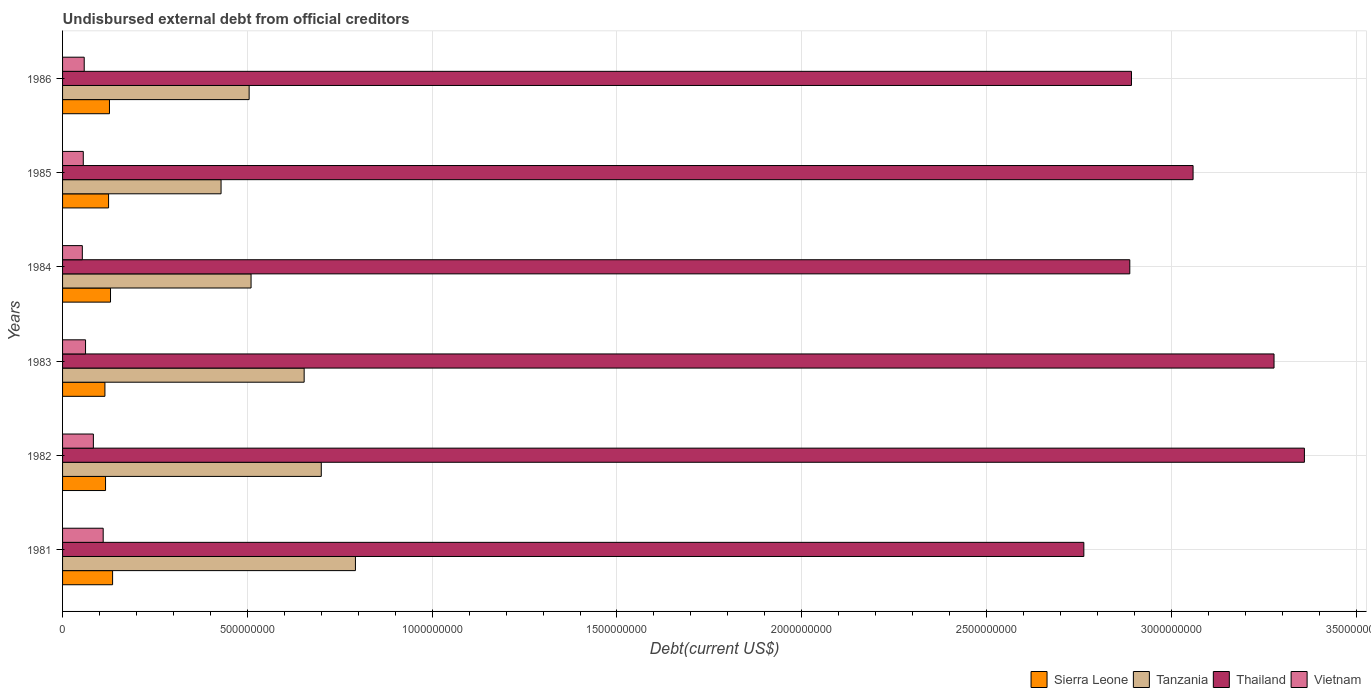How many bars are there on the 2nd tick from the top?
Keep it short and to the point. 4. How many bars are there on the 3rd tick from the bottom?
Offer a very short reply. 4. What is the total debt in Sierra Leone in 1986?
Your answer should be compact. 1.27e+08. Across all years, what is the maximum total debt in Thailand?
Offer a terse response. 3.36e+09. Across all years, what is the minimum total debt in Thailand?
Ensure brevity in your answer.  2.76e+09. In which year was the total debt in Tanzania maximum?
Offer a very short reply. 1981. What is the total total debt in Tanzania in the graph?
Your response must be concise. 3.59e+09. What is the difference between the total debt in Thailand in 1985 and that in 1986?
Give a very brief answer. 1.67e+08. What is the difference between the total debt in Tanzania in 1981 and the total debt in Vietnam in 1985?
Make the answer very short. 7.36e+08. What is the average total debt in Sierra Leone per year?
Your answer should be very brief. 1.25e+08. In the year 1982, what is the difference between the total debt in Tanzania and total debt in Sierra Leone?
Provide a short and direct response. 5.84e+08. What is the ratio of the total debt in Thailand in 1982 to that in 1986?
Offer a terse response. 1.16. What is the difference between the highest and the second highest total debt in Thailand?
Your answer should be very brief. 8.22e+07. What is the difference between the highest and the lowest total debt in Tanzania?
Offer a terse response. 3.64e+08. Is the sum of the total debt in Tanzania in 1983 and 1985 greater than the maximum total debt in Sierra Leone across all years?
Provide a short and direct response. Yes. What does the 4th bar from the top in 1982 represents?
Provide a succinct answer. Sierra Leone. What does the 1st bar from the bottom in 1984 represents?
Offer a very short reply. Sierra Leone. Is it the case that in every year, the sum of the total debt in Vietnam and total debt in Tanzania is greater than the total debt in Thailand?
Give a very brief answer. No. How many bars are there?
Your answer should be very brief. 24. Are all the bars in the graph horizontal?
Your answer should be compact. Yes. How many years are there in the graph?
Make the answer very short. 6. Does the graph contain grids?
Your answer should be very brief. Yes. Where does the legend appear in the graph?
Ensure brevity in your answer.  Bottom right. How many legend labels are there?
Your answer should be compact. 4. What is the title of the graph?
Provide a succinct answer. Undisbursed external debt from official creditors. What is the label or title of the X-axis?
Keep it short and to the point. Debt(current US$). What is the Debt(current US$) in Sierra Leone in 1981?
Keep it short and to the point. 1.35e+08. What is the Debt(current US$) in Tanzania in 1981?
Offer a terse response. 7.92e+08. What is the Debt(current US$) in Thailand in 1981?
Give a very brief answer. 2.76e+09. What is the Debt(current US$) in Vietnam in 1981?
Keep it short and to the point. 1.10e+08. What is the Debt(current US$) of Sierra Leone in 1982?
Give a very brief answer. 1.16e+08. What is the Debt(current US$) in Tanzania in 1982?
Give a very brief answer. 7.00e+08. What is the Debt(current US$) of Thailand in 1982?
Offer a terse response. 3.36e+09. What is the Debt(current US$) in Vietnam in 1982?
Your response must be concise. 8.34e+07. What is the Debt(current US$) in Sierra Leone in 1983?
Your response must be concise. 1.15e+08. What is the Debt(current US$) in Tanzania in 1983?
Make the answer very short. 6.54e+08. What is the Debt(current US$) in Thailand in 1983?
Make the answer very short. 3.28e+09. What is the Debt(current US$) of Vietnam in 1983?
Give a very brief answer. 6.22e+07. What is the Debt(current US$) in Sierra Leone in 1984?
Offer a very short reply. 1.30e+08. What is the Debt(current US$) in Tanzania in 1984?
Ensure brevity in your answer.  5.10e+08. What is the Debt(current US$) of Thailand in 1984?
Your answer should be compact. 2.89e+09. What is the Debt(current US$) in Vietnam in 1984?
Make the answer very short. 5.35e+07. What is the Debt(current US$) of Sierra Leone in 1985?
Offer a very short reply. 1.24e+08. What is the Debt(current US$) in Tanzania in 1985?
Ensure brevity in your answer.  4.29e+08. What is the Debt(current US$) of Thailand in 1985?
Offer a terse response. 3.06e+09. What is the Debt(current US$) of Vietnam in 1985?
Your answer should be very brief. 5.60e+07. What is the Debt(current US$) of Sierra Leone in 1986?
Make the answer very short. 1.27e+08. What is the Debt(current US$) of Tanzania in 1986?
Offer a very short reply. 5.05e+08. What is the Debt(current US$) in Thailand in 1986?
Ensure brevity in your answer.  2.89e+09. What is the Debt(current US$) of Vietnam in 1986?
Your answer should be very brief. 5.86e+07. Across all years, what is the maximum Debt(current US$) of Sierra Leone?
Give a very brief answer. 1.35e+08. Across all years, what is the maximum Debt(current US$) of Tanzania?
Your answer should be very brief. 7.92e+08. Across all years, what is the maximum Debt(current US$) in Thailand?
Give a very brief answer. 3.36e+09. Across all years, what is the maximum Debt(current US$) in Vietnam?
Your response must be concise. 1.10e+08. Across all years, what is the minimum Debt(current US$) of Sierra Leone?
Your answer should be compact. 1.15e+08. Across all years, what is the minimum Debt(current US$) in Tanzania?
Your answer should be very brief. 4.29e+08. Across all years, what is the minimum Debt(current US$) in Thailand?
Keep it short and to the point. 2.76e+09. Across all years, what is the minimum Debt(current US$) in Vietnam?
Keep it short and to the point. 5.35e+07. What is the total Debt(current US$) of Sierra Leone in the graph?
Give a very brief answer. 7.47e+08. What is the total Debt(current US$) of Tanzania in the graph?
Give a very brief answer. 3.59e+09. What is the total Debt(current US$) in Thailand in the graph?
Your response must be concise. 1.82e+1. What is the total Debt(current US$) in Vietnam in the graph?
Make the answer very short. 4.24e+08. What is the difference between the Debt(current US$) in Sierra Leone in 1981 and that in 1982?
Keep it short and to the point. 1.91e+07. What is the difference between the Debt(current US$) in Tanzania in 1981 and that in 1982?
Ensure brevity in your answer.  9.24e+07. What is the difference between the Debt(current US$) of Thailand in 1981 and that in 1982?
Your answer should be very brief. -5.97e+08. What is the difference between the Debt(current US$) of Vietnam in 1981 and that in 1982?
Keep it short and to the point. 2.65e+07. What is the difference between the Debt(current US$) in Sierra Leone in 1981 and that in 1983?
Make the answer very short. 2.08e+07. What is the difference between the Debt(current US$) in Tanzania in 1981 and that in 1983?
Give a very brief answer. 1.39e+08. What is the difference between the Debt(current US$) of Thailand in 1981 and that in 1983?
Provide a succinct answer. -5.15e+08. What is the difference between the Debt(current US$) in Vietnam in 1981 and that in 1983?
Provide a short and direct response. 4.77e+07. What is the difference between the Debt(current US$) of Sierra Leone in 1981 and that in 1984?
Provide a succinct answer. 5.64e+06. What is the difference between the Debt(current US$) in Tanzania in 1981 and that in 1984?
Offer a very short reply. 2.82e+08. What is the difference between the Debt(current US$) of Thailand in 1981 and that in 1984?
Give a very brief answer. -1.24e+08. What is the difference between the Debt(current US$) in Vietnam in 1981 and that in 1984?
Provide a short and direct response. 5.64e+07. What is the difference between the Debt(current US$) in Sierra Leone in 1981 and that in 1985?
Provide a succinct answer. 1.09e+07. What is the difference between the Debt(current US$) of Tanzania in 1981 and that in 1985?
Your answer should be very brief. 3.64e+08. What is the difference between the Debt(current US$) of Thailand in 1981 and that in 1985?
Provide a short and direct response. -2.96e+08. What is the difference between the Debt(current US$) in Vietnam in 1981 and that in 1985?
Provide a succinct answer. 5.39e+07. What is the difference between the Debt(current US$) of Sierra Leone in 1981 and that in 1986?
Give a very brief answer. 8.49e+06. What is the difference between the Debt(current US$) in Tanzania in 1981 and that in 1986?
Your answer should be very brief. 2.88e+08. What is the difference between the Debt(current US$) in Thailand in 1981 and that in 1986?
Give a very brief answer. -1.29e+08. What is the difference between the Debt(current US$) of Vietnam in 1981 and that in 1986?
Offer a very short reply. 5.13e+07. What is the difference between the Debt(current US$) in Sierra Leone in 1982 and that in 1983?
Provide a short and direct response. 1.68e+06. What is the difference between the Debt(current US$) in Tanzania in 1982 and that in 1983?
Make the answer very short. 4.63e+07. What is the difference between the Debt(current US$) in Thailand in 1982 and that in 1983?
Provide a short and direct response. 8.22e+07. What is the difference between the Debt(current US$) of Vietnam in 1982 and that in 1983?
Your answer should be compact. 2.12e+07. What is the difference between the Debt(current US$) of Sierra Leone in 1982 and that in 1984?
Offer a very short reply. -1.35e+07. What is the difference between the Debt(current US$) in Tanzania in 1982 and that in 1984?
Keep it short and to the point. 1.90e+08. What is the difference between the Debt(current US$) in Thailand in 1982 and that in 1984?
Offer a very short reply. 4.72e+08. What is the difference between the Debt(current US$) in Vietnam in 1982 and that in 1984?
Your answer should be very brief. 2.99e+07. What is the difference between the Debt(current US$) in Sierra Leone in 1982 and that in 1985?
Offer a terse response. -8.21e+06. What is the difference between the Debt(current US$) in Tanzania in 1982 and that in 1985?
Keep it short and to the point. 2.71e+08. What is the difference between the Debt(current US$) in Thailand in 1982 and that in 1985?
Provide a short and direct response. 3.01e+08. What is the difference between the Debt(current US$) in Vietnam in 1982 and that in 1985?
Ensure brevity in your answer.  2.73e+07. What is the difference between the Debt(current US$) of Sierra Leone in 1982 and that in 1986?
Provide a short and direct response. -1.06e+07. What is the difference between the Debt(current US$) of Tanzania in 1982 and that in 1986?
Provide a short and direct response. 1.95e+08. What is the difference between the Debt(current US$) in Thailand in 1982 and that in 1986?
Make the answer very short. 4.68e+08. What is the difference between the Debt(current US$) in Vietnam in 1982 and that in 1986?
Offer a very short reply. 2.48e+07. What is the difference between the Debt(current US$) in Sierra Leone in 1983 and that in 1984?
Keep it short and to the point. -1.51e+07. What is the difference between the Debt(current US$) in Tanzania in 1983 and that in 1984?
Make the answer very short. 1.44e+08. What is the difference between the Debt(current US$) in Thailand in 1983 and that in 1984?
Your answer should be compact. 3.90e+08. What is the difference between the Debt(current US$) of Vietnam in 1983 and that in 1984?
Give a very brief answer. 8.70e+06. What is the difference between the Debt(current US$) of Sierra Leone in 1983 and that in 1985?
Ensure brevity in your answer.  -9.88e+06. What is the difference between the Debt(current US$) of Tanzania in 1983 and that in 1985?
Make the answer very short. 2.25e+08. What is the difference between the Debt(current US$) in Thailand in 1983 and that in 1985?
Make the answer very short. 2.19e+08. What is the difference between the Debt(current US$) of Vietnam in 1983 and that in 1985?
Give a very brief answer. 6.14e+06. What is the difference between the Debt(current US$) in Sierra Leone in 1983 and that in 1986?
Ensure brevity in your answer.  -1.23e+07. What is the difference between the Debt(current US$) in Tanzania in 1983 and that in 1986?
Your response must be concise. 1.49e+08. What is the difference between the Debt(current US$) of Thailand in 1983 and that in 1986?
Offer a very short reply. 3.86e+08. What is the difference between the Debt(current US$) in Vietnam in 1983 and that in 1986?
Your answer should be compact. 3.58e+06. What is the difference between the Debt(current US$) of Sierra Leone in 1984 and that in 1985?
Make the answer very short. 5.25e+06. What is the difference between the Debt(current US$) of Tanzania in 1984 and that in 1985?
Your answer should be very brief. 8.12e+07. What is the difference between the Debt(current US$) in Thailand in 1984 and that in 1985?
Make the answer very short. -1.71e+08. What is the difference between the Debt(current US$) in Vietnam in 1984 and that in 1985?
Offer a very short reply. -2.56e+06. What is the difference between the Debt(current US$) of Sierra Leone in 1984 and that in 1986?
Your answer should be very brief. 2.85e+06. What is the difference between the Debt(current US$) in Tanzania in 1984 and that in 1986?
Give a very brief answer. 5.18e+06. What is the difference between the Debt(current US$) in Thailand in 1984 and that in 1986?
Your answer should be compact. -4.50e+06. What is the difference between the Debt(current US$) of Vietnam in 1984 and that in 1986?
Ensure brevity in your answer.  -5.11e+06. What is the difference between the Debt(current US$) of Sierra Leone in 1985 and that in 1986?
Ensure brevity in your answer.  -2.40e+06. What is the difference between the Debt(current US$) in Tanzania in 1985 and that in 1986?
Your response must be concise. -7.60e+07. What is the difference between the Debt(current US$) in Thailand in 1985 and that in 1986?
Your response must be concise. 1.67e+08. What is the difference between the Debt(current US$) of Vietnam in 1985 and that in 1986?
Offer a very short reply. -2.55e+06. What is the difference between the Debt(current US$) of Sierra Leone in 1981 and the Debt(current US$) of Tanzania in 1982?
Provide a succinct answer. -5.65e+08. What is the difference between the Debt(current US$) in Sierra Leone in 1981 and the Debt(current US$) in Thailand in 1982?
Your answer should be very brief. -3.22e+09. What is the difference between the Debt(current US$) in Sierra Leone in 1981 and the Debt(current US$) in Vietnam in 1982?
Your answer should be very brief. 5.20e+07. What is the difference between the Debt(current US$) in Tanzania in 1981 and the Debt(current US$) in Thailand in 1982?
Offer a very short reply. -2.57e+09. What is the difference between the Debt(current US$) of Tanzania in 1981 and the Debt(current US$) of Vietnam in 1982?
Offer a very short reply. 7.09e+08. What is the difference between the Debt(current US$) of Thailand in 1981 and the Debt(current US$) of Vietnam in 1982?
Make the answer very short. 2.68e+09. What is the difference between the Debt(current US$) in Sierra Leone in 1981 and the Debt(current US$) in Tanzania in 1983?
Your answer should be very brief. -5.18e+08. What is the difference between the Debt(current US$) of Sierra Leone in 1981 and the Debt(current US$) of Thailand in 1983?
Offer a terse response. -3.14e+09. What is the difference between the Debt(current US$) of Sierra Leone in 1981 and the Debt(current US$) of Vietnam in 1983?
Keep it short and to the point. 7.32e+07. What is the difference between the Debt(current US$) of Tanzania in 1981 and the Debt(current US$) of Thailand in 1983?
Offer a very short reply. -2.49e+09. What is the difference between the Debt(current US$) in Tanzania in 1981 and the Debt(current US$) in Vietnam in 1983?
Make the answer very short. 7.30e+08. What is the difference between the Debt(current US$) of Thailand in 1981 and the Debt(current US$) of Vietnam in 1983?
Your answer should be very brief. 2.70e+09. What is the difference between the Debt(current US$) in Sierra Leone in 1981 and the Debt(current US$) in Tanzania in 1984?
Your response must be concise. -3.75e+08. What is the difference between the Debt(current US$) of Sierra Leone in 1981 and the Debt(current US$) of Thailand in 1984?
Keep it short and to the point. -2.75e+09. What is the difference between the Debt(current US$) in Sierra Leone in 1981 and the Debt(current US$) in Vietnam in 1984?
Your answer should be very brief. 8.19e+07. What is the difference between the Debt(current US$) of Tanzania in 1981 and the Debt(current US$) of Thailand in 1984?
Provide a succinct answer. -2.10e+09. What is the difference between the Debt(current US$) in Tanzania in 1981 and the Debt(current US$) in Vietnam in 1984?
Your answer should be very brief. 7.39e+08. What is the difference between the Debt(current US$) of Thailand in 1981 and the Debt(current US$) of Vietnam in 1984?
Your answer should be compact. 2.71e+09. What is the difference between the Debt(current US$) in Sierra Leone in 1981 and the Debt(current US$) in Tanzania in 1985?
Make the answer very short. -2.93e+08. What is the difference between the Debt(current US$) in Sierra Leone in 1981 and the Debt(current US$) in Thailand in 1985?
Offer a very short reply. -2.92e+09. What is the difference between the Debt(current US$) in Sierra Leone in 1981 and the Debt(current US$) in Vietnam in 1985?
Give a very brief answer. 7.93e+07. What is the difference between the Debt(current US$) in Tanzania in 1981 and the Debt(current US$) in Thailand in 1985?
Make the answer very short. -2.27e+09. What is the difference between the Debt(current US$) in Tanzania in 1981 and the Debt(current US$) in Vietnam in 1985?
Give a very brief answer. 7.36e+08. What is the difference between the Debt(current US$) of Thailand in 1981 and the Debt(current US$) of Vietnam in 1985?
Provide a short and direct response. 2.71e+09. What is the difference between the Debt(current US$) in Sierra Leone in 1981 and the Debt(current US$) in Tanzania in 1986?
Offer a very short reply. -3.69e+08. What is the difference between the Debt(current US$) of Sierra Leone in 1981 and the Debt(current US$) of Thailand in 1986?
Provide a short and direct response. -2.76e+09. What is the difference between the Debt(current US$) of Sierra Leone in 1981 and the Debt(current US$) of Vietnam in 1986?
Your answer should be compact. 7.68e+07. What is the difference between the Debt(current US$) of Tanzania in 1981 and the Debt(current US$) of Thailand in 1986?
Your response must be concise. -2.10e+09. What is the difference between the Debt(current US$) in Tanzania in 1981 and the Debt(current US$) in Vietnam in 1986?
Offer a very short reply. 7.34e+08. What is the difference between the Debt(current US$) of Thailand in 1981 and the Debt(current US$) of Vietnam in 1986?
Give a very brief answer. 2.70e+09. What is the difference between the Debt(current US$) of Sierra Leone in 1982 and the Debt(current US$) of Tanzania in 1983?
Give a very brief answer. -5.37e+08. What is the difference between the Debt(current US$) of Sierra Leone in 1982 and the Debt(current US$) of Thailand in 1983?
Your answer should be very brief. -3.16e+09. What is the difference between the Debt(current US$) in Sierra Leone in 1982 and the Debt(current US$) in Vietnam in 1983?
Provide a short and direct response. 5.41e+07. What is the difference between the Debt(current US$) in Tanzania in 1982 and the Debt(current US$) in Thailand in 1983?
Keep it short and to the point. -2.58e+09. What is the difference between the Debt(current US$) in Tanzania in 1982 and the Debt(current US$) in Vietnam in 1983?
Offer a very short reply. 6.38e+08. What is the difference between the Debt(current US$) in Thailand in 1982 and the Debt(current US$) in Vietnam in 1983?
Keep it short and to the point. 3.30e+09. What is the difference between the Debt(current US$) of Sierra Leone in 1982 and the Debt(current US$) of Tanzania in 1984?
Offer a very short reply. -3.94e+08. What is the difference between the Debt(current US$) in Sierra Leone in 1982 and the Debt(current US$) in Thailand in 1984?
Keep it short and to the point. -2.77e+09. What is the difference between the Debt(current US$) in Sierra Leone in 1982 and the Debt(current US$) in Vietnam in 1984?
Give a very brief answer. 6.28e+07. What is the difference between the Debt(current US$) in Tanzania in 1982 and the Debt(current US$) in Thailand in 1984?
Your answer should be very brief. -2.19e+09. What is the difference between the Debt(current US$) of Tanzania in 1982 and the Debt(current US$) of Vietnam in 1984?
Your response must be concise. 6.46e+08. What is the difference between the Debt(current US$) in Thailand in 1982 and the Debt(current US$) in Vietnam in 1984?
Ensure brevity in your answer.  3.31e+09. What is the difference between the Debt(current US$) in Sierra Leone in 1982 and the Debt(current US$) in Tanzania in 1985?
Provide a succinct answer. -3.13e+08. What is the difference between the Debt(current US$) in Sierra Leone in 1982 and the Debt(current US$) in Thailand in 1985?
Give a very brief answer. -2.94e+09. What is the difference between the Debt(current US$) of Sierra Leone in 1982 and the Debt(current US$) of Vietnam in 1985?
Ensure brevity in your answer.  6.02e+07. What is the difference between the Debt(current US$) in Tanzania in 1982 and the Debt(current US$) in Thailand in 1985?
Provide a short and direct response. -2.36e+09. What is the difference between the Debt(current US$) in Tanzania in 1982 and the Debt(current US$) in Vietnam in 1985?
Keep it short and to the point. 6.44e+08. What is the difference between the Debt(current US$) in Thailand in 1982 and the Debt(current US$) in Vietnam in 1985?
Make the answer very short. 3.30e+09. What is the difference between the Debt(current US$) in Sierra Leone in 1982 and the Debt(current US$) in Tanzania in 1986?
Give a very brief answer. -3.89e+08. What is the difference between the Debt(current US$) in Sierra Leone in 1982 and the Debt(current US$) in Thailand in 1986?
Your answer should be very brief. -2.78e+09. What is the difference between the Debt(current US$) in Sierra Leone in 1982 and the Debt(current US$) in Vietnam in 1986?
Ensure brevity in your answer.  5.77e+07. What is the difference between the Debt(current US$) in Tanzania in 1982 and the Debt(current US$) in Thailand in 1986?
Offer a terse response. -2.19e+09. What is the difference between the Debt(current US$) of Tanzania in 1982 and the Debt(current US$) of Vietnam in 1986?
Keep it short and to the point. 6.41e+08. What is the difference between the Debt(current US$) of Thailand in 1982 and the Debt(current US$) of Vietnam in 1986?
Make the answer very short. 3.30e+09. What is the difference between the Debt(current US$) of Sierra Leone in 1983 and the Debt(current US$) of Tanzania in 1984?
Your response must be concise. -3.95e+08. What is the difference between the Debt(current US$) of Sierra Leone in 1983 and the Debt(current US$) of Thailand in 1984?
Your answer should be compact. -2.77e+09. What is the difference between the Debt(current US$) of Sierra Leone in 1983 and the Debt(current US$) of Vietnam in 1984?
Offer a very short reply. 6.11e+07. What is the difference between the Debt(current US$) of Tanzania in 1983 and the Debt(current US$) of Thailand in 1984?
Your answer should be compact. -2.23e+09. What is the difference between the Debt(current US$) of Tanzania in 1983 and the Debt(current US$) of Vietnam in 1984?
Ensure brevity in your answer.  6.00e+08. What is the difference between the Debt(current US$) of Thailand in 1983 and the Debt(current US$) of Vietnam in 1984?
Offer a terse response. 3.22e+09. What is the difference between the Debt(current US$) of Sierra Leone in 1983 and the Debt(current US$) of Tanzania in 1985?
Offer a very short reply. -3.14e+08. What is the difference between the Debt(current US$) in Sierra Leone in 1983 and the Debt(current US$) in Thailand in 1985?
Your answer should be compact. -2.94e+09. What is the difference between the Debt(current US$) of Sierra Leone in 1983 and the Debt(current US$) of Vietnam in 1985?
Keep it short and to the point. 5.86e+07. What is the difference between the Debt(current US$) in Tanzania in 1983 and the Debt(current US$) in Thailand in 1985?
Your answer should be compact. -2.41e+09. What is the difference between the Debt(current US$) of Tanzania in 1983 and the Debt(current US$) of Vietnam in 1985?
Your answer should be very brief. 5.98e+08. What is the difference between the Debt(current US$) in Thailand in 1983 and the Debt(current US$) in Vietnam in 1985?
Offer a terse response. 3.22e+09. What is the difference between the Debt(current US$) of Sierra Leone in 1983 and the Debt(current US$) of Tanzania in 1986?
Provide a short and direct response. -3.90e+08. What is the difference between the Debt(current US$) in Sierra Leone in 1983 and the Debt(current US$) in Thailand in 1986?
Keep it short and to the point. -2.78e+09. What is the difference between the Debt(current US$) of Sierra Leone in 1983 and the Debt(current US$) of Vietnam in 1986?
Make the answer very short. 5.60e+07. What is the difference between the Debt(current US$) of Tanzania in 1983 and the Debt(current US$) of Thailand in 1986?
Keep it short and to the point. -2.24e+09. What is the difference between the Debt(current US$) of Tanzania in 1983 and the Debt(current US$) of Vietnam in 1986?
Your response must be concise. 5.95e+08. What is the difference between the Debt(current US$) in Thailand in 1983 and the Debt(current US$) in Vietnam in 1986?
Offer a very short reply. 3.22e+09. What is the difference between the Debt(current US$) in Sierra Leone in 1984 and the Debt(current US$) in Tanzania in 1985?
Keep it short and to the point. -2.99e+08. What is the difference between the Debt(current US$) of Sierra Leone in 1984 and the Debt(current US$) of Thailand in 1985?
Make the answer very short. -2.93e+09. What is the difference between the Debt(current US$) of Sierra Leone in 1984 and the Debt(current US$) of Vietnam in 1985?
Give a very brief answer. 7.37e+07. What is the difference between the Debt(current US$) in Tanzania in 1984 and the Debt(current US$) in Thailand in 1985?
Ensure brevity in your answer.  -2.55e+09. What is the difference between the Debt(current US$) of Tanzania in 1984 and the Debt(current US$) of Vietnam in 1985?
Give a very brief answer. 4.54e+08. What is the difference between the Debt(current US$) in Thailand in 1984 and the Debt(current US$) in Vietnam in 1985?
Offer a very short reply. 2.83e+09. What is the difference between the Debt(current US$) of Sierra Leone in 1984 and the Debt(current US$) of Tanzania in 1986?
Your response must be concise. -3.75e+08. What is the difference between the Debt(current US$) of Sierra Leone in 1984 and the Debt(current US$) of Thailand in 1986?
Make the answer very short. -2.76e+09. What is the difference between the Debt(current US$) of Sierra Leone in 1984 and the Debt(current US$) of Vietnam in 1986?
Offer a terse response. 7.11e+07. What is the difference between the Debt(current US$) of Tanzania in 1984 and the Debt(current US$) of Thailand in 1986?
Offer a terse response. -2.38e+09. What is the difference between the Debt(current US$) of Tanzania in 1984 and the Debt(current US$) of Vietnam in 1986?
Keep it short and to the point. 4.51e+08. What is the difference between the Debt(current US$) in Thailand in 1984 and the Debt(current US$) in Vietnam in 1986?
Provide a short and direct response. 2.83e+09. What is the difference between the Debt(current US$) in Sierra Leone in 1985 and the Debt(current US$) in Tanzania in 1986?
Provide a succinct answer. -3.80e+08. What is the difference between the Debt(current US$) of Sierra Leone in 1985 and the Debt(current US$) of Thailand in 1986?
Offer a terse response. -2.77e+09. What is the difference between the Debt(current US$) in Sierra Leone in 1985 and the Debt(current US$) in Vietnam in 1986?
Give a very brief answer. 6.59e+07. What is the difference between the Debt(current US$) in Tanzania in 1985 and the Debt(current US$) in Thailand in 1986?
Keep it short and to the point. -2.46e+09. What is the difference between the Debt(current US$) of Tanzania in 1985 and the Debt(current US$) of Vietnam in 1986?
Provide a succinct answer. 3.70e+08. What is the difference between the Debt(current US$) of Thailand in 1985 and the Debt(current US$) of Vietnam in 1986?
Your answer should be compact. 3.00e+09. What is the average Debt(current US$) of Sierra Leone per year?
Ensure brevity in your answer.  1.25e+08. What is the average Debt(current US$) of Tanzania per year?
Provide a succinct answer. 5.98e+08. What is the average Debt(current US$) in Thailand per year?
Make the answer very short. 3.04e+09. What is the average Debt(current US$) of Vietnam per year?
Your answer should be compact. 7.06e+07. In the year 1981, what is the difference between the Debt(current US$) in Sierra Leone and Debt(current US$) in Tanzania?
Provide a succinct answer. -6.57e+08. In the year 1981, what is the difference between the Debt(current US$) of Sierra Leone and Debt(current US$) of Thailand?
Give a very brief answer. -2.63e+09. In the year 1981, what is the difference between the Debt(current US$) of Sierra Leone and Debt(current US$) of Vietnam?
Your answer should be very brief. 2.55e+07. In the year 1981, what is the difference between the Debt(current US$) in Tanzania and Debt(current US$) in Thailand?
Make the answer very short. -1.97e+09. In the year 1981, what is the difference between the Debt(current US$) of Tanzania and Debt(current US$) of Vietnam?
Keep it short and to the point. 6.82e+08. In the year 1981, what is the difference between the Debt(current US$) in Thailand and Debt(current US$) in Vietnam?
Your answer should be compact. 2.65e+09. In the year 1982, what is the difference between the Debt(current US$) of Sierra Leone and Debt(current US$) of Tanzania?
Offer a very short reply. -5.84e+08. In the year 1982, what is the difference between the Debt(current US$) in Sierra Leone and Debt(current US$) in Thailand?
Provide a succinct answer. -3.24e+09. In the year 1982, what is the difference between the Debt(current US$) in Sierra Leone and Debt(current US$) in Vietnam?
Provide a succinct answer. 3.29e+07. In the year 1982, what is the difference between the Debt(current US$) of Tanzania and Debt(current US$) of Thailand?
Give a very brief answer. -2.66e+09. In the year 1982, what is the difference between the Debt(current US$) of Tanzania and Debt(current US$) of Vietnam?
Your response must be concise. 6.17e+08. In the year 1982, what is the difference between the Debt(current US$) in Thailand and Debt(current US$) in Vietnam?
Keep it short and to the point. 3.28e+09. In the year 1983, what is the difference between the Debt(current US$) in Sierra Leone and Debt(current US$) in Tanzania?
Give a very brief answer. -5.39e+08. In the year 1983, what is the difference between the Debt(current US$) of Sierra Leone and Debt(current US$) of Thailand?
Your response must be concise. -3.16e+09. In the year 1983, what is the difference between the Debt(current US$) of Sierra Leone and Debt(current US$) of Vietnam?
Your answer should be very brief. 5.24e+07. In the year 1983, what is the difference between the Debt(current US$) in Tanzania and Debt(current US$) in Thailand?
Provide a succinct answer. -2.62e+09. In the year 1983, what is the difference between the Debt(current US$) of Tanzania and Debt(current US$) of Vietnam?
Keep it short and to the point. 5.91e+08. In the year 1983, what is the difference between the Debt(current US$) in Thailand and Debt(current US$) in Vietnam?
Provide a short and direct response. 3.22e+09. In the year 1984, what is the difference between the Debt(current US$) in Sierra Leone and Debt(current US$) in Tanzania?
Give a very brief answer. -3.80e+08. In the year 1984, what is the difference between the Debt(current US$) of Sierra Leone and Debt(current US$) of Thailand?
Keep it short and to the point. -2.76e+09. In the year 1984, what is the difference between the Debt(current US$) of Sierra Leone and Debt(current US$) of Vietnam?
Make the answer very short. 7.62e+07. In the year 1984, what is the difference between the Debt(current US$) in Tanzania and Debt(current US$) in Thailand?
Offer a terse response. -2.38e+09. In the year 1984, what is the difference between the Debt(current US$) of Tanzania and Debt(current US$) of Vietnam?
Your response must be concise. 4.56e+08. In the year 1984, what is the difference between the Debt(current US$) of Thailand and Debt(current US$) of Vietnam?
Ensure brevity in your answer.  2.83e+09. In the year 1985, what is the difference between the Debt(current US$) of Sierra Leone and Debt(current US$) of Tanzania?
Offer a very short reply. -3.04e+08. In the year 1985, what is the difference between the Debt(current US$) of Sierra Leone and Debt(current US$) of Thailand?
Make the answer very short. -2.93e+09. In the year 1985, what is the difference between the Debt(current US$) in Sierra Leone and Debt(current US$) in Vietnam?
Give a very brief answer. 6.84e+07. In the year 1985, what is the difference between the Debt(current US$) of Tanzania and Debt(current US$) of Thailand?
Offer a terse response. -2.63e+09. In the year 1985, what is the difference between the Debt(current US$) in Tanzania and Debt(current US$) in Vietnam?
Your answer should be very brief. 3.73e+08. In the year 1985, what is the difference between the Debt(current US$) of Thailand and Debt(current US$) of Vietnam?
Provide a short and direct response. 3.00e+09. In the year 1986, what is the difference between the Debt(current US$) in Sierra Leone and Debt(current US$) in Tanzania?
Provide a short and direct response. -3.78e+08. In the year 1986, what is the difference between the Debt(current US$) of Sierra Leone and Debt(current US$) of Thailand?
Your answer should be very brief. -2.77e+09. In the year 1986, what is the difference between the Debt(current US$) in Sierra Leone and Debt(current US$) in Vietnam?
Your answer should be very brief. 6.83e+07. In the year 1986, what is the difference between the Debt(current US$) of Tanzania and Debt(current US$) of Thailand?
Your answer should be very brief. -2.39e+09. In the year 1986, what is the difference between the Debt(current US$) of Tanzania and Debt(current US$) of Vietnam?
Offer a very short reply. 4.46e+08. In the year 1986, what is the difference between the Debt(current US$) in Thailand and Debt(current US$) in Vietnam?
Ensure brevity in your answer.  2.83e+09. What is the ratio of the Debt(current US$) in Sierra Leone in 1981 to that in 1982?
Your answer should be very brief. 1.16. What is the ratio of the Debt(current US$) of Tanzania in 1981 to that in 1982?
Offer a terse response. 1.13. What is the ratio of the Debt(current US$) of Thailand in 1981 to that in 1982?
Keep it short and to the point. 0.82. What is the ratio of the Debt(current US$) in Vietnam in 1981 to that in 1982?
Provide a short and direct response. 1.32. What is the ratio of the Debt(current US$) in Sierra Leone in 1981 to that in 1983?
Your answer should be compact. 1.18. What is the ratio of the Debt(current US$) of Tanzania in 1981 to that in 1983?
Give a very brief answer. 1.21. What is the ratio of the Debt(current US$) of Thailand in 1981 to that in 1983?
Make the answer very short. 0.84. What is the ratio of the Debt(current US$) in Vietnam in 1981 to that in 1983?
Provide a succinct answer. 1.77. What is the ratio of the Debt(current US$) of Sierra Leone in 1981 to that in 1984?
Give a very brief answer. 1.04. What is the ratio of the Debt(current US$) in Tanzania in 1981 to that in 1984?
Provide a succinct answer. 1.55. What is the ratio of the Debt(current US$) in Thailand in 1981 to that in 1984?
Make the answer very short. 0.96. What is the ratio of the Debt(current US$) of Vietnam in 1981 to that in 1984?
Offer a terse response. 2.05. What is the ratio of the Debt(current US$) in Sierra Leone in 1981 to that in 1985?
Keep it short and to the point. 1.09. What is the ratio of the Debt(current US$) in Tanzania in 1981 to that in 1985?
Make the answer very short. 1.85. What is the ratio of the Debt(current US$) in Thailand in 1981 to that in 1985?
Give a very brief answer. 0.9. What is the ratio of the Debt(current US$) of Vietnam in 1981 to that in 1985?
Give a very brief answer. 1.96. What is the ratio of the Debt(current US$) in Sierra Leone in 1981 to that in 1986?
Your answer should be compact. 1.07. What is the ratio of the Debt(current US$) in Tanzania in 1981 to that in 1986?
Give a very brief answer. 1.57. What is the ratio of the Debt(current US$) in Thailand in 1981 to that in 1986?
Give a very brief answer. 0.96. What is the ratio of the Debt(current US$) of Vietnam in 1981 to that in 1986?
Ensure brevity in your answer.  1.88. What is the ratio of the Debt(current US$) in Sierra Leone in 1982 to that in 1983?
Your answer should be very brief. 1.01. What is the ratio of the Debt(current US$) in Tanzania in 1982 to that in 1983?
Give a very brief answer. 1.07. What is the ratio of the Debt(current US$) of Thailand in 1982 to that in 1983?
Keep it short and to the point. 1.03. What is the ratio of the Debt(current US$) in Vietnam in 1982 to that in 1983?
Provide a short and direct response. 1.34. What is the ratio of the Debt(current US$) in Sierra Leone in 1982 to that in 1984?
Make the answer very short. 0.9. What is the ratio of the Debt(current US$) in Tanzania in 1982 to that in 1984?
Provide a succinct answer. 1.37. What is the ratio of the Debt(current US$) in Thailand in 1982 to that in 1984?
Your answer should be compact. 1.16. What is the ratio of the Debt(current US$) in Vietnam in 1982 to that in 1984?
Your answer should be compact. 1.56. What is the ratio of the Debt(current US$) in Sierra Leone in 1982 to that in 1985?
Offer a very short reply. 0.93. What is the ratio of the Debt(current US$) of Tanzania in 1982 to that in 1985?
Give a very brief answer. 1.63. What is the ratio of the Debt(current US$) in Thailand in 1982 to that in 1985?
Ensure brevity in your answer.  1.1. What is the ratio of the Debt(current US$) of Vietnam in 1982 to that in 1985?
Offer a very short reply. 1.49. What is the ratio of the Debt(current US$) in Sierra Leone in 1982 to that in 1986?
Your answer should be compact. 0.92. What is the ratio of the Debt(current US$) of Tanzania in 1982 to that in 1986?
Offer a terse response. 1.39. What is the ratio of the Debt(current US$) in Thailand in 1982 to that in 1986?
Provide a short and direct response. 1.16. What is the ratio of the Debt(current US$) in Vietnam in 1982 to that in 1986?
Your answer should be compact. 1.42. What is the ratio of the Debt(current US$) of Sierra Leone in 1983 to that in 1984?
Ensure brevity in your answer.  0.88. What is the ratio of the Debt(current US$) of Tanzania in 1983 to that in 1984?
Give a very brief answer. 1.28. What is the ratio of the Debt(current US$) of Thailand in 1983 to that in 1984?
Provide a succinct answer. 1.14. What is the ratio of the Debt(current US$) in Vietnam in 1983 to that in 1984?
Keep it short and to the point. 1.16. What is the ratio of the Debt(current US$) of Sierra Leone in 1983 to that in 1985?
Offer a very short reply. 0.92. What is the ratio of the Debt(current US$) in Tanzania in 1983 to that in 1985?
Your response must be concise. 1.52. What is the ratio of the Debt(current US$) in Thailand in 1983 to that in 1985?
Offer a terse response. 1.07. What is the ratio of the Debt(current US$) in Vietnam in 1983 to that in 1985?
Provide a succinct answer. 1.11. What is the ratio of the Debt(current US$) of Sierra Leone in 1983 to that in 1986?
Make the answer very short. 0.9. What is the ratio of the Debt(current US$) of Tanzania in 1983 to that in 1986?
Make the answer very short. 1.29. What is the ratio of the Debt(current US$) in Thailand in 1983 to that in 1986?
Offer a terse response. 1.13. What is the ratio of the Debt(current US$) in Vietnam in 1983 to that in 1986?
Make the answer very short. 1.06. What is the ratio of the Debt(current US$) in Sierra Leone in 1984 to that in 1985?
Give a very brief answer. 1.04. What is the ratio of the Debt(current US$) in Tanzania in 1984 to that in 1985?
Offer a terse response. 1.19. What is the ratio of the Debt(current US$) of Thailand in 1984 to that in 1985?
Keep it short and to the point. 0.94. What is the ratio of the Debt(current US$) in Vietnam in 1984 to that in 1985?
Your answer should be very brief. 0.95. What is the ratio of the Debt(current US$) of Sierra Leone in 1984 to that in 1986?
Make the answer very short. 1.02. What is the ratio of the Debt(current US$) in Tanzania in 1984 to that in 1986?
Offer a very short reply. 1.01. What is the ratio of the Debt(current US$) of Vietnam in 1984 to that in 1986?
Offer a terse response. 0.91. What is the ratio of the Debt(current US$) of Sierra Leone in 1985 to that in 1986?
Keep it short and to the point. 0.98. What is the ratio of the Debt(current US$) in Tanzania in 1985 to that in 1986?
Keep it short and to the point. 0.85. What is the ratio of the Debt(current US$) in Thailand in 1985 to that in 1986?
Give a very brief answer. 1.06. What is the ratio of the Debt(current US$) of Vietnam in 1985 to that in 1986?
Ensure brevity in your answer.  0.96. What is the difference between the highest and the second highest Debt(current US$) in Sierra Leone?
Offer a very short reply. 5.64e+06. What is the difference between the highest and the second highest Debt(current US$) of Tanzania?
Provide a short and direct response. 9.24e+07. What is the difference between the highest and the second highest Debt(current US$) in Thailand?
Your answer should be very brief. 8.22e+07. What is the difference between the highest and the second highest Debt(current US$) of Vietnam?
Offer a very short reply. 2.65e+07. What is the difference between the highest and the lowest Debt(current US$) of Sierra Leone?
Provide a short and direct response. 2.08e+07. What is the difference between the highest and the lowest Debt(current US$) of Tanzania?
Provide a succinct answer. 3.64e+08. What is the difference between the highest and the lowest Debt(current US$) of Thailand?
Ensure brevity in your answer.  5.97e+08. What is the difference between the highest and the lowest Debt(current US$) of Vietnam?
Your answer should be very brief. 5.64e+07. 